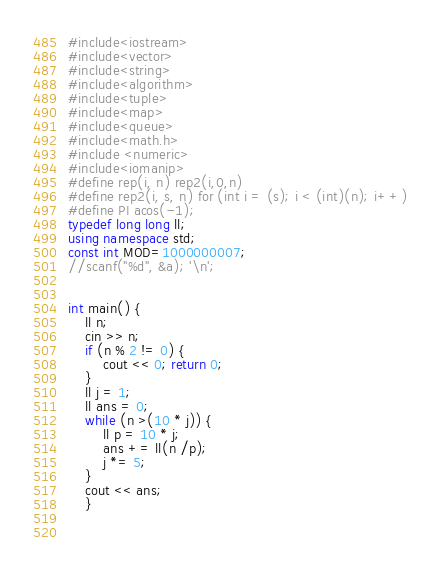<code> <loc_0><loc_0><loc_500><loc_500><_C++_>#include<iostream>
#include<vector>
#include<string>
#include<algorithm>
#include<tuple>
#include<map>
#include<queue>
#include<math.h>
#include <numeric>
#include<iomanip>
#define rep(i, n) rep2(i,0,n)
#define rep2(i, s, n) for (int i = (s); i < (int)(n); i++)
#define PI acos(-1);
typedef long long ll;
using namespace std;
const int MOD=1000000007;
//scanf("%d", &a); '\n';


int main() {
	ll n;
	cin >> n;
	if (n % 2 != 0) {
		cout << 0; return 0;
	}
	ll j = 1;
	ll ans = 0;
	while (n >(10 * j)) {
		ll p = 10 * j;
		ans += ll(n /p);
		j *= 5;
	}
	cout << ans;
	}

	</code> 